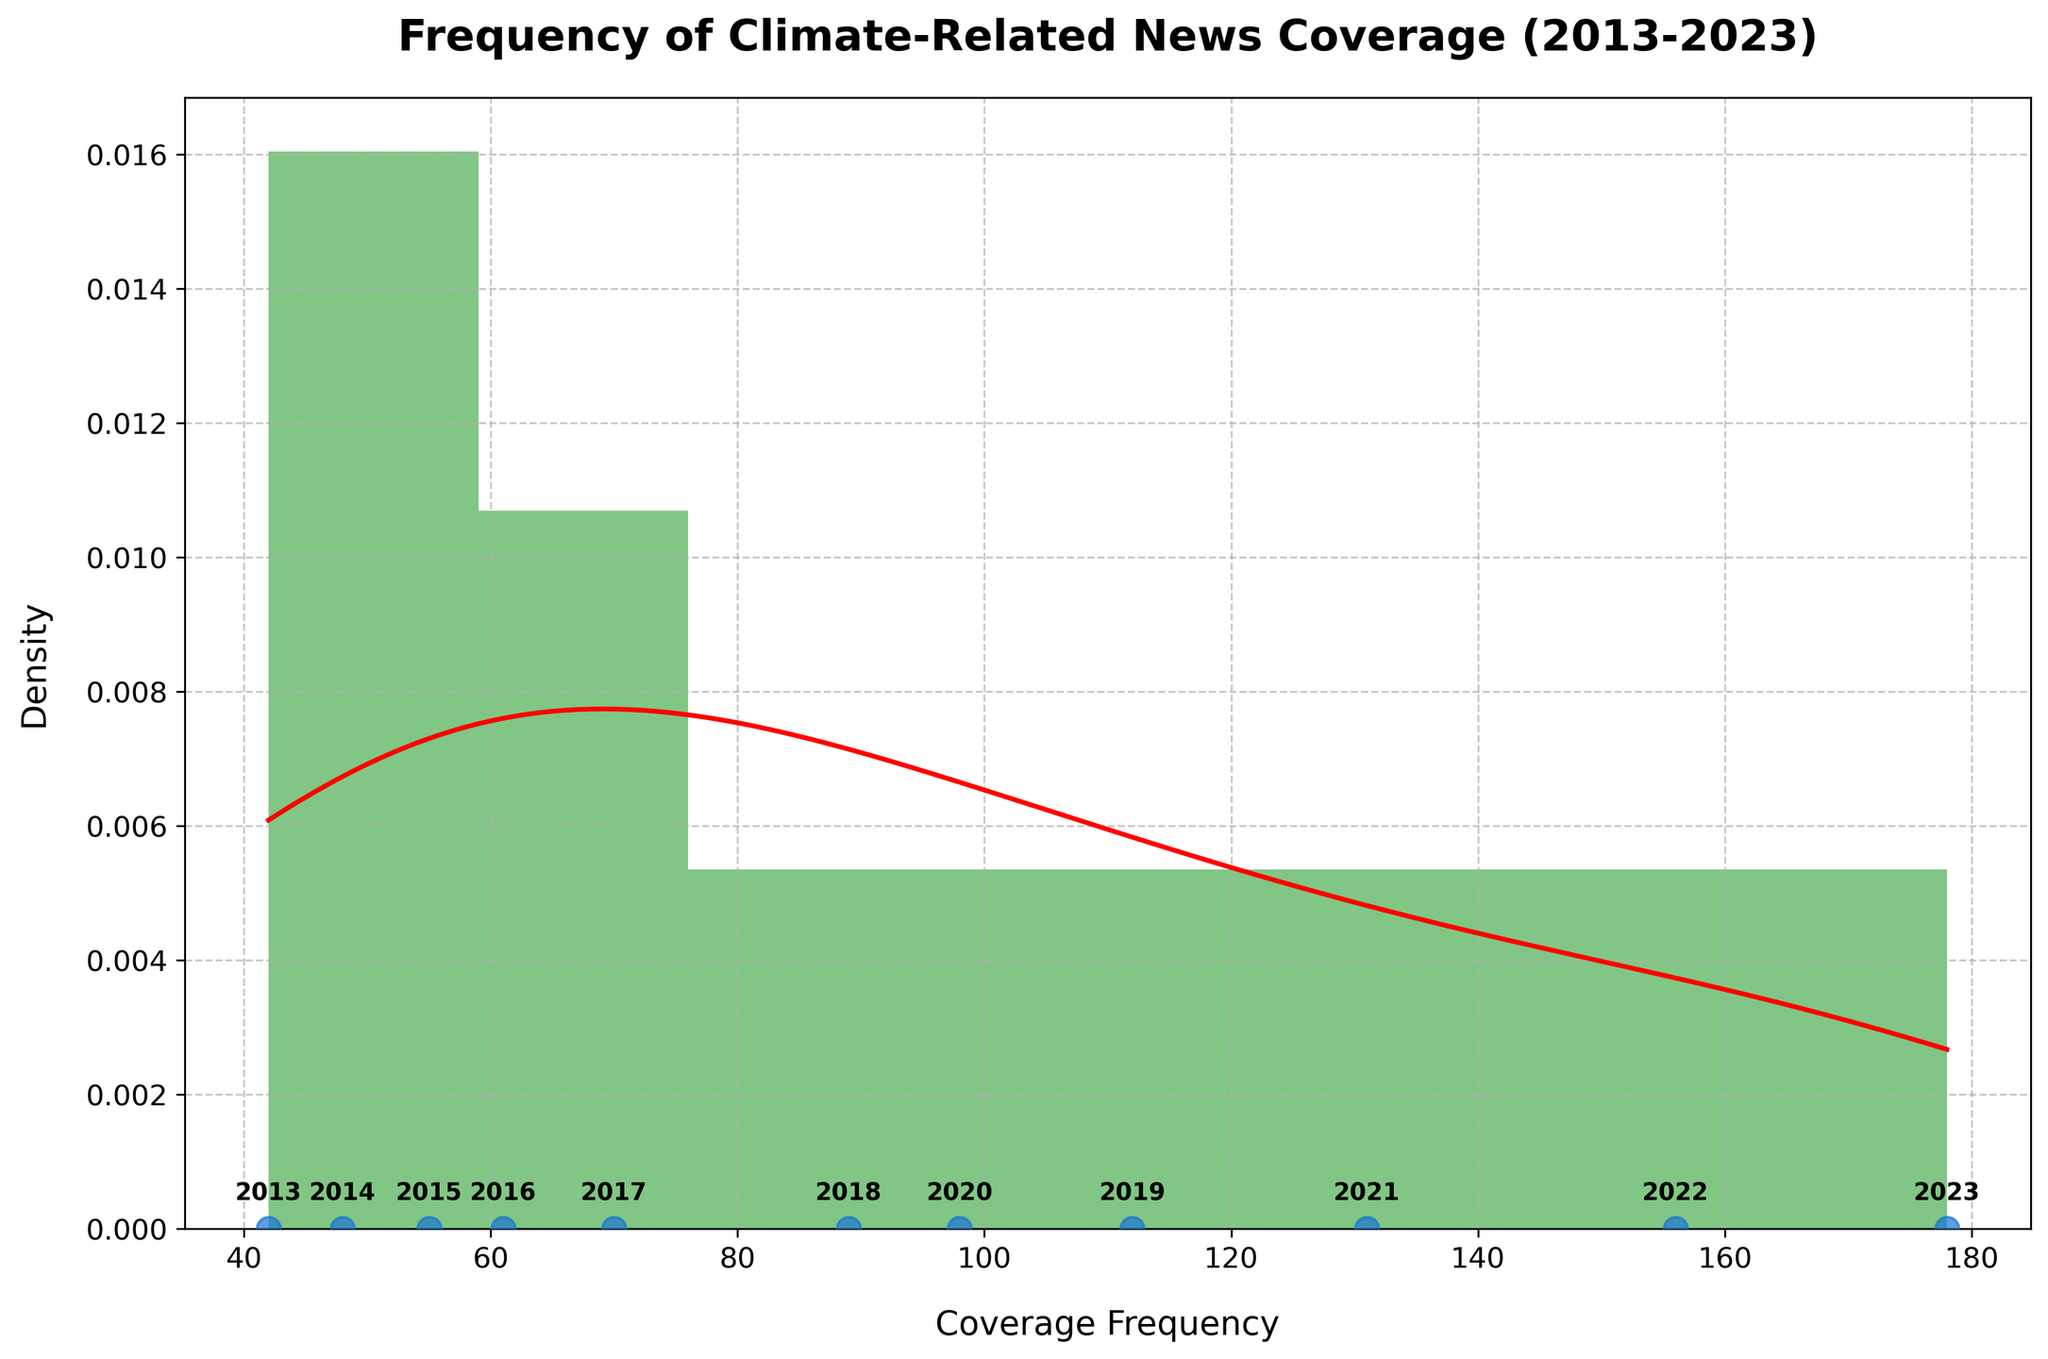What is the title of the figure? The title of the figure is located at the top and states the main subject of the plot. The title here is "Frequency of Climate-Related News Coverage (2013-2023)."
Answer: Frequency of Climate-Related News Coverage (2013-2023) What is the range of the Coverage Frequency on the x-axis? The x-axis ranges from the minimum to the maximum values of coverage frequency in the dataset. The histogram starts around 40 and ends around 180.
Answer: 40 to 180 What is the color of the density curve (KDE)? The density curve (KDE) is visually distinct and is plotted in a red line. This helps to distinguish it from the histogram bars.
Answer: Red How many bins are there in the histogram? By looking at the histogram, you can count the number of bars (bins) present. There are 8 bins displayed in the histogram.
Answer: 8 Which year had the highest frequency of climate-related news coverage? The highest point on the density curve indicates the year with the highest frequency. Annotated data points show that the year 2023 had the highest frequency at 178.
Answer: 2023 What is the median frequency of the coverage data points? To find the median, you need to arrange the frequencies in ascending order and find the middle value. The sorted frequencies are 42, 48, 55, 61, 70, 89, 98, 112, 131, 156, 178. The median is the 6th value, which is 89.
Answer: 89 How does the coverage frequency in 2016 compare to that in 2019? Comparing the annotated coverage frequencies for both years, 2016 had a value of 61, and 2019 had a value of 112. Thus, 2019 had substantially higher coverage frequency than 2016.
Answer: 2019 had higher coverage What can you infer from the KDE curve about the distribution of the coverage frequencies? The KDE curve gives a smooth estimate of the distribution of coverage frequencies. Most values are clustered around the middle range between 60 to 130, indicating higher densities in these ranges with frequencies gradually tapering off towards the higher ends.
Answer: Higher density around 60-130 Which year showed a notable increase in coverage from the previous year? By examining the year annotations and frequencies on the x-axis, you can see the difference from one year to the next. The increase from 2017 (70) to 2018 (89), by 19 units, is noticeable.
Answer: 2018 What's the overall trend observed in the coverage frequency over the years? The overall trend can be seen by looking at the annotated points and their progression from left to right on the x-axis. There's a clear upward trend in the frequency of climate-related news coverage from 2013 to 2023.
Answer: Upward trend 